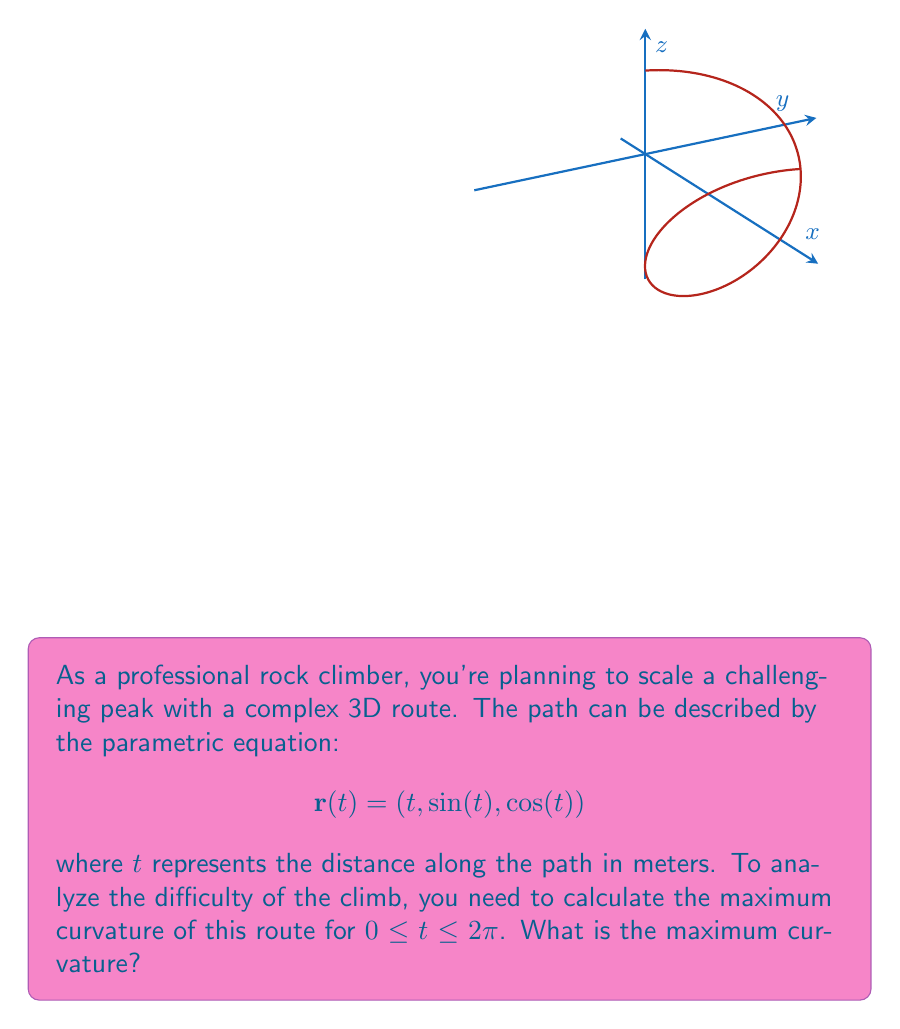Show me your answer to this math problem. To find the maximum curvature, we'll follow these steps:

1) The curvature $\kappa$ of a parametric curve is given by:

   $$\kappa = \frac{|\mathbf{r}'(t) \times \mathbf{r}''(t)|}{|\mathbf{r}'(t)|^3}$$

2) Calculate $\mathbf{r}'(t)$:
   $$\mathbf{r}'(t) = (1, \cos(t), -\sin(t))$$

3) Calculate $\mathbf{r}''(t)$:
   $$\mathbf{r}''(t) = (0, -\sin(t), -\cos(t))$$

4) Calculate $\mathbf{r}'(t) \times \mathbf{r}''(t)$:
   $$\mathbf{r}'(t) \times \mathbf{r}''(t) = (\cos^2(t) + \sin^2(t), \sin(t), \cos(t)) = (1, \sin(t), \cos(t))$$

5) Calculate $|\mathbf{r}'(t) \times \mathbf{r}''(t)|$:
   $$|\mathbf{r}'(t) \times \mathbf{r}''(t)| = \sqrt{1^2 + \sin^2(t) + \cos^2(t)} = \sqrt{2}$$

6) Calculate $|\mathbf{r}'(t)|$:
   $$|\mathbf{r}'(t)| = \sqrt{1^2 + \cos^2(t) + \sin^2(t)} = \sqrt{2}$$

7) Now, we can calculate the curvature:
   $$\kappa = \frac{\sqrt{2}}{(\sqrt{2})^3} = \frac{1}{\sqrt{2}}$$

8) Since the curvature is constant, the maximum curvature is also $\frac{1}{\sqrt{2}}$.
Answer: $\frac{1}{\sqrt{2}}$ 